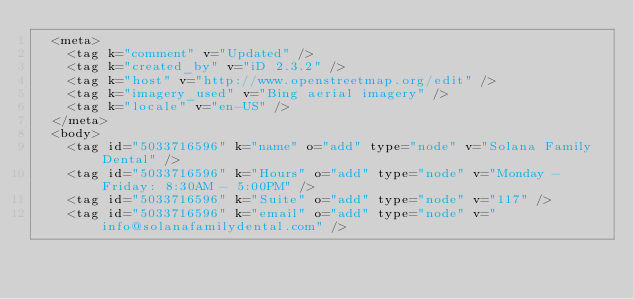Convert code to text. <code><loc_0><loc_0><loc_500><loc_500><_XML_>  <meta>
    <tag k="comment" v="Updated" />
    <tag k="created_by" v="iD 2.3.2" />
    <tag k="host" v="http://www.openstreetmap.org/edit" />
    <tag k="imagery_used" v="Bing aerial imagery" />
    <tag k="locale" v="en-US" />
  </meta>
  <body>
    <tag id="5033716596" k="name" o="add" type="node" v="Solana Family Dental" />
    <tag id="5033716596" k="Hours" o="add" type="node" v="Monday - Friday: 8:30AM - 5:00PM" />
    <tag id="5033716596" k="Suite" o="add" type="node" v="117" />
    <tag id="5033716596" k="email" o="add" type="node" v="info@solanafamilydental.com" /></code> 